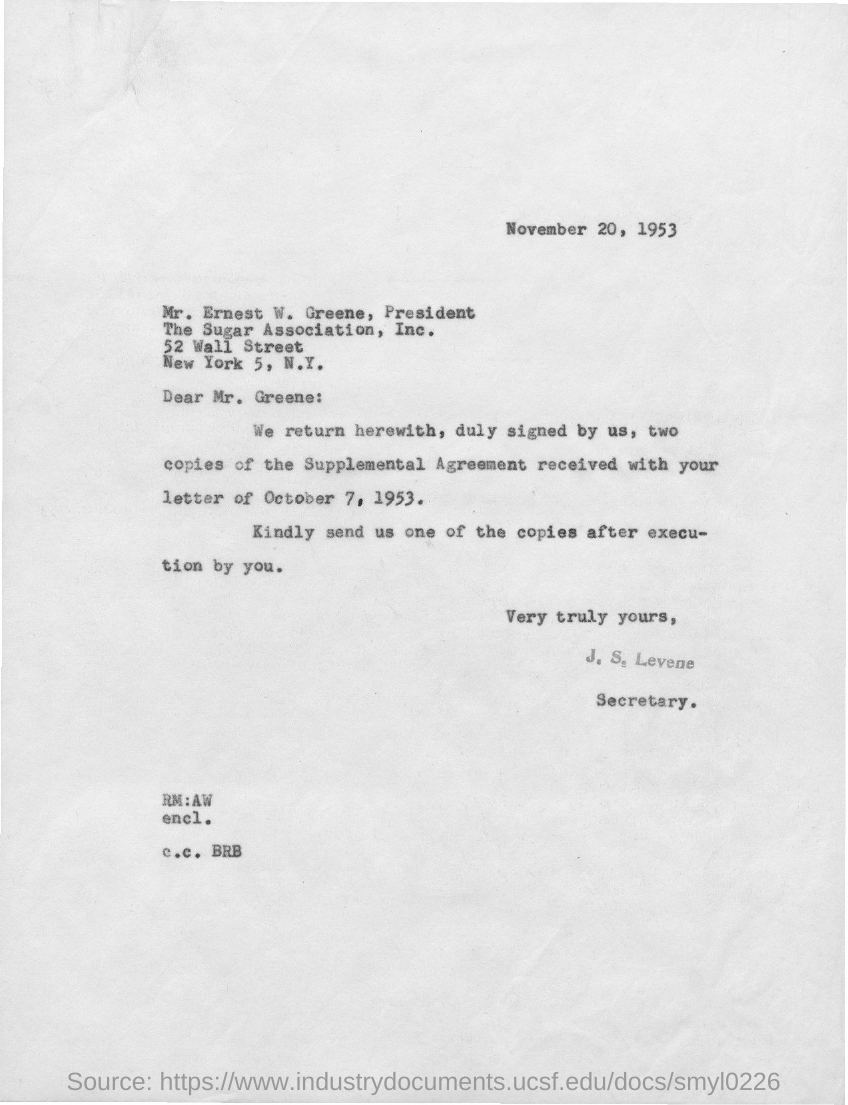Mention a couple of crucial points in this snapshot. The issued date of this letter is November 20, 1953. The individual designated as J. S. Levene is serving as Secretary... The sender of this letter is J. S. Levene. The addressee of this letter is Mr. Greene. 